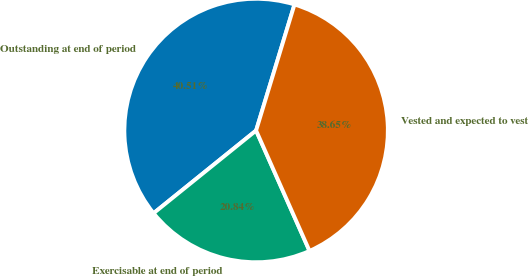Convert chart to OTSL. <chart><loc_0><loc_0><loc_500><loc_500><pie_chart><fcel>Outstanding at end of period<fcel>Exercisable at end of period<fcel>Vested and expected to vest<nl><fcel>40.51%<fcel>20.84%<fcel>38.65%<nl></chart> 